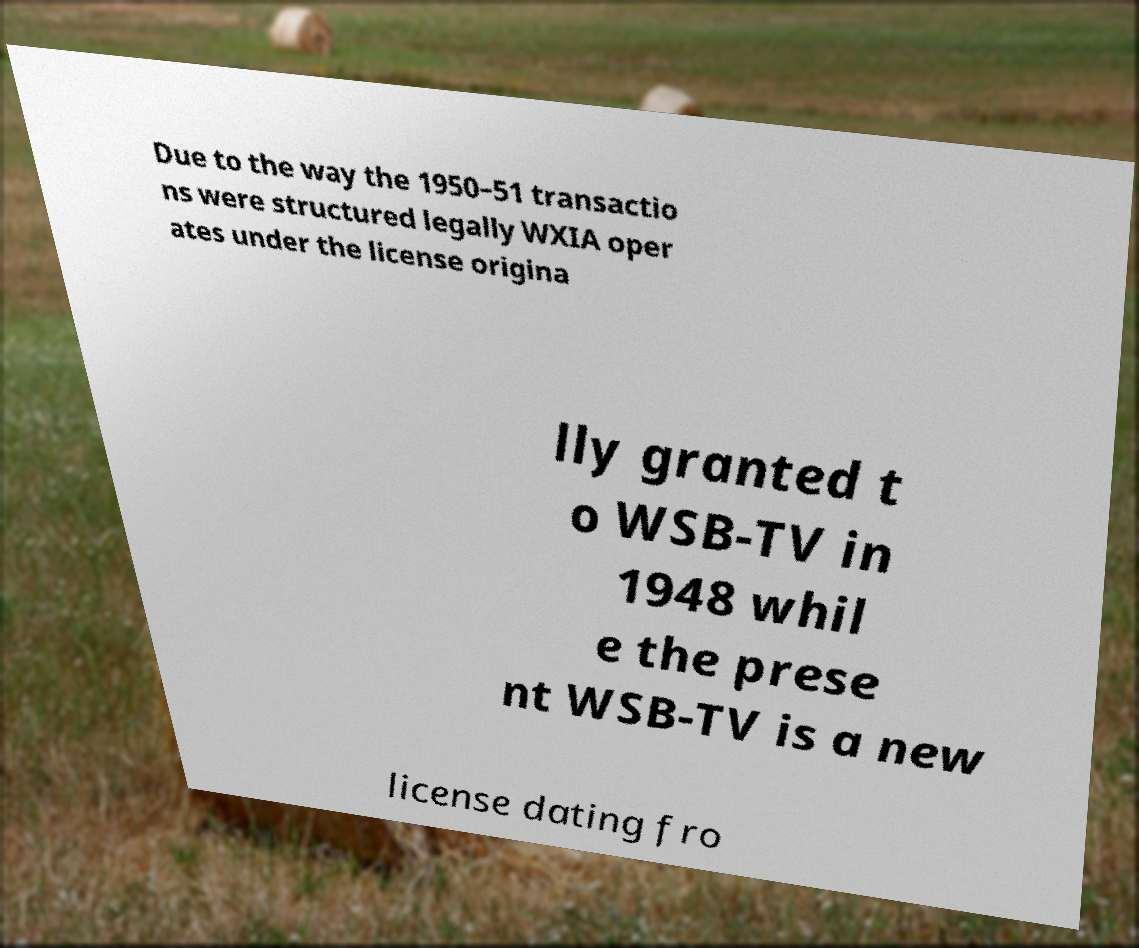There's text embedded in this image that I need extracted. Can you transcribe it verbatim? Due to the way the 1950–51 transactio ns were structured legally WXIA oper ates under the license origina lly granted t o WSB-TV in 1948 whil e the prese nt WSB-TV is a new license dating fro 